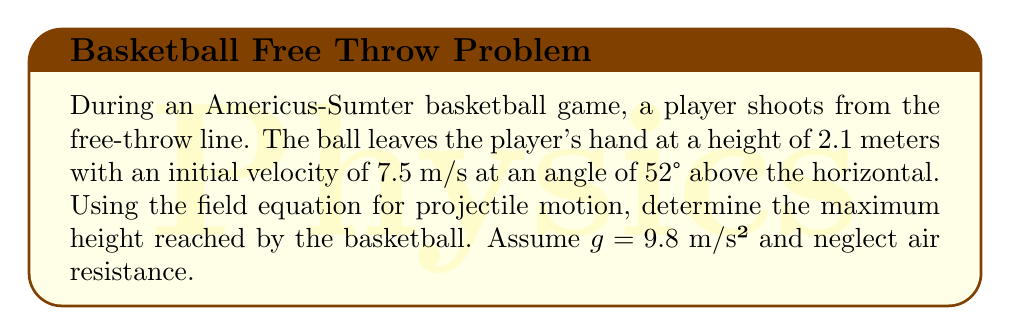Can you answer this question? To solve this problem, we'll use the field equation for the vertical component of projectile motion:

$$y(t) = y_0 + v_0\sin(\theta)t - \frac{1}{2}gt^2$$

Where:
$y(t)$ is the height at time $t$
$y_0$ is the initial height (2.1 m)
$v_0$ is the initial velocity (7.5 m/s)
$\theta$ is the launch angle (52°)
$g$ is the acceleration due to gravity (9.8 m/s²)

Steps to find the maximum height:

1) The maximum height occurs when the vertical velocity is zero. We can find this time using:

   $$v_y(t) = v_0\sin(\theta) - gt = 0$$
   $$t_{max} = \frac{v_0\sin(\theta)}{g}$$

2) Calculate $t_{max}$:
   $$t_{max} = \frac{7.5 \cdot \sin(52°)}{9.8} \approx 0.5918 \text{ s}$$

3) Substitute this time into the original equation:

   $$y_{max} = 2.1 + 7.5\sin(52°)(0.5918) - \frac{1}{2}(9.8)(0.5918)^2$$

4) Evaluate:
   $$y_{max} = 2.1 + 4.4385 - 1.7163 = 4.8222 \text{ m}$$

Therefore, the maximum height reached by the basketball is approximately 4.82 meters.
Answer: 4.82 m 